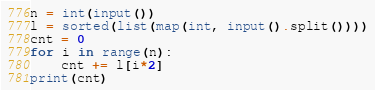Convert code to text. <code><loc_0><loc_0><loc_500><loc_500><_Python_>n = int(input())
l = sorted(list(map(int, input().split())))
cnt = 0
for i in range(n):
    cnt += l[i*2]
print(cnt)</code> 